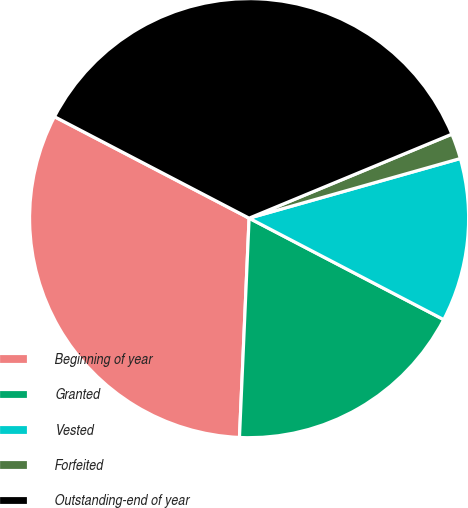Convert chart. <chart><loc_0><loc_0><loc_500><loc_500><pie_chart><fcel>Beginning of year<fcel>Granted<fcel>Vested<fcel>Forfeited<fcel>Outstanding-end of year<nl><fcel>31.95%<fcel>18.05%<fcel>12.03%<fcel>1.87%<fcel>36.1%<nl></chart> 